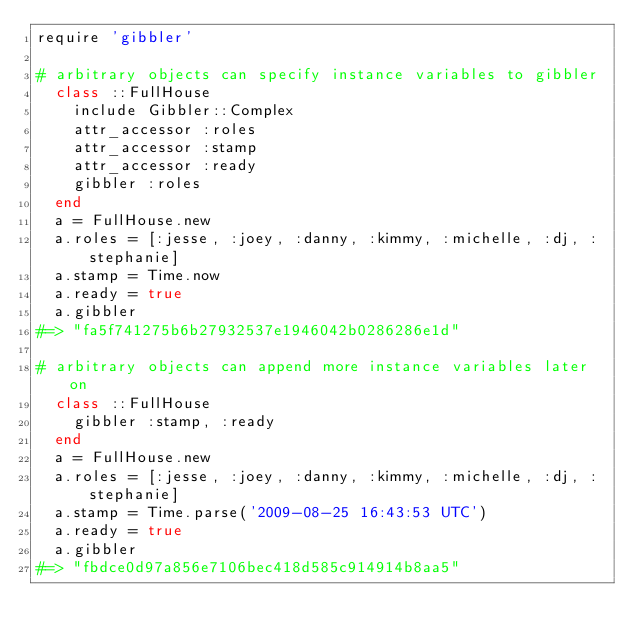Convert code to text. <code><loc_0><loc_0><loc_500><loc_500><_Ruby_>require 'gibbler'

# arbitrary objects can specify instance variables to gibbler
  class ::FullHouse
    include Gibbler::Complex
    attr_accessor :roles
    attr_accessor :stamp
    attr_accessor :ready
    gibbler :roles
  end
  a = FullHouse.new
  a.roles = [:jesse, :joey, :danny, :kimmy, :michelle, :dj, :stephanie]
  a.stamp = Time.now
  a.ready = true
  a.gibbler
#=> "fa5f741275b6b27932537e1946042b0286286e1d"

# arbitrary objects can append more instance variables later on
  class ::FullHouse
    gibbler :stamp, :ready
  end
  a = FullHouse.new
  a.roles = [:jesse, :joey, :danny, :kimmy, :michelle, :dj, :stephanie]
  a.stamp = Time.parse('2009-08-25 16:43:53 UTC')
  a.ready = true
  a.gibbler
#=> "fbdce0d97a856e7106bec418d585c914914b8aa5"
</code> 